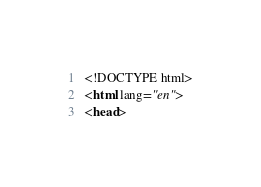Convert code to text. <code><loc_0><loc_0><loc_500><loc_500><_HTML_><!DOCTYPE html>
<html lang="en">
<head></code> 